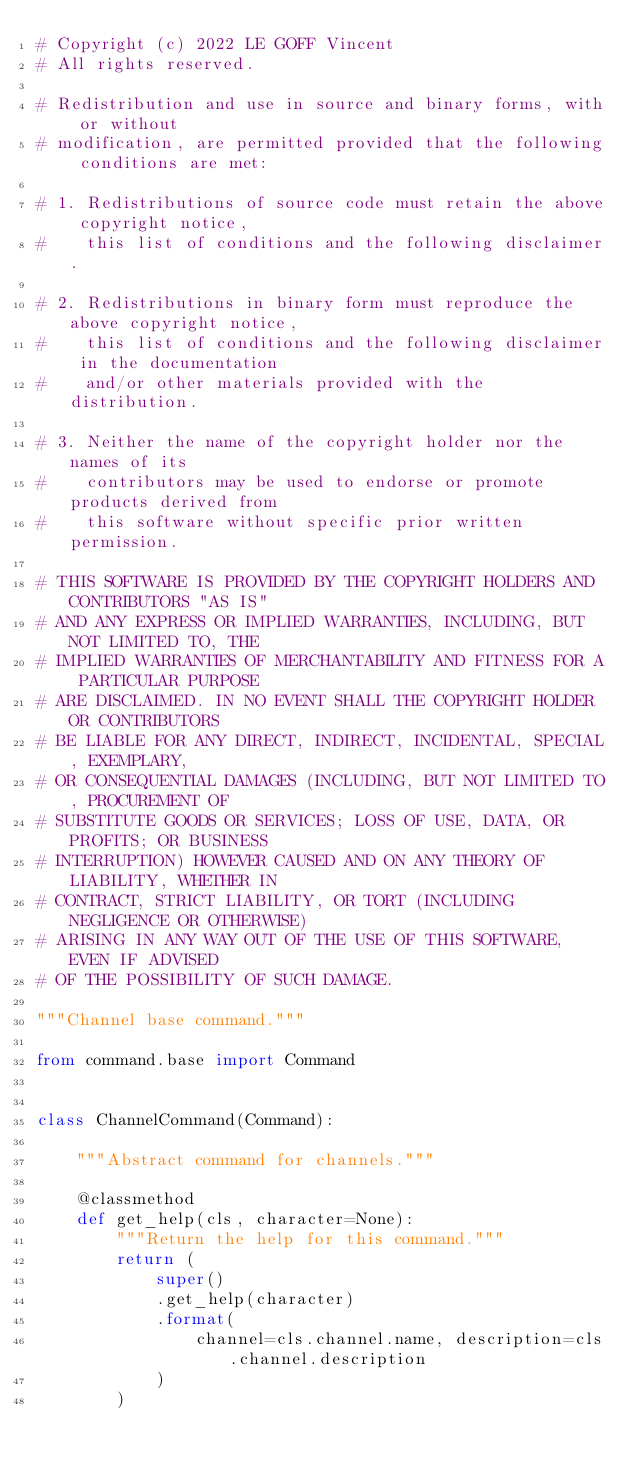<code> <loc_0><loc_0><loc_500><loc_500><_Python_># Copyright (c) 2022 LE GOFF Vincent
# All rights reserved.

# Redistribution and use in source and binary forms, with or without
# modification, are permitted provided that the following conditions are met:

# 1. Redistributions of source code must retain the above copyright notice,
#    this list of conditions and the following disclaimer.

# 2. Redistributions in binary form must reproduce the above copyright notice,
#    this list of conditions and the following disclaimer in the documentation
#    and/or other materials provided with the distribution.

# 3. Neither the name of the copyright holder nor the names of its
#    contributors may be used to endorse or promote products derived from
#    this software without specific prior written permission.

# THIS SOFTWARE IS PROVIDED BY THE COPYRIGHT HOLDERS AND CONTRIBUTORS "AS IS"
# AND ANY EXPRESS OR IMPLIED WARRANTIES, INCLUDING, BUT NOT LIMITED TO, THE
# IMPLIED WARRANTIES OF MERCHANTABILITY AND FITNESS FOR A PARTICULAR PURPOSE
# ARE DISCLAIMED. IN NO EVENT SHALL THE COPYRIGHT HOLDER OR CONTRIBUTORS
# BE LIABLE FOR ANY DIRECT, INDIRECT, INCIDENTAL, SPECIAL, EXEMPLARY,
# OR CONSEQUENTIAL DAMAGES (INCLUDING, BUT NOT LIMITED TO, PROCUREMENT OF
# SUBSTITUTE GOODS OR SERVICES; LOSS OF USE, DATA, OR PROFITS; OR BUSINESS
# INTERRUPTION) HOWEVER CAUSED AND ON ANY THEORY OF LIABILITY, WHETHER IN
# CONTRACT, STRICT LIABILITY, OR TORT (INCLUDING NEGLIGENCE OR OTHERWISE)
# ARISING IN ANY WAY OUT OF THE USE OF THIS SOFTWARE, EVEN IF ADVISED
# OF THE POSSIBILITY OF SUCH DAMAGE.

"""Channel base command."""

from command.base import Command


class ChannelCommand(Command):

    """Abstract command for channels."""

    @classmethod
    def get_help(cls, character=None):
        """Return the help for this command."""
        return (
            super()
            .get_help(character)
            .format(
                channel=cls.channel.name, description=cls.channel.description
            )
        )
</code> 